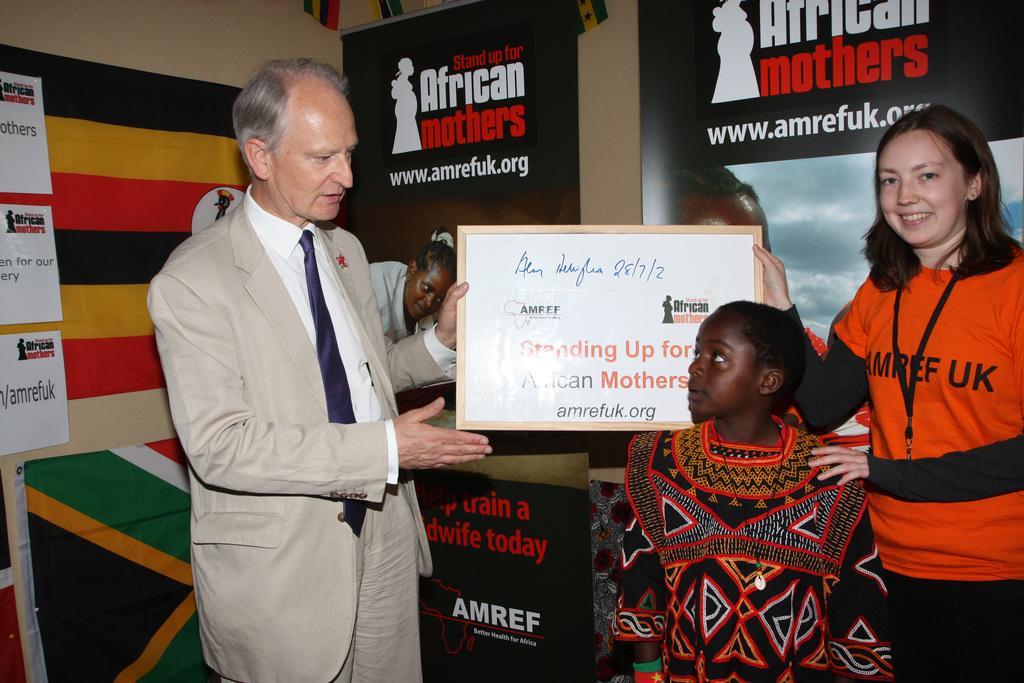In one or two sentences, can you explain what this image depicts? In this picture I can see there is a man standing and he is holding a certificate and there is a woman standing on the right side and there is a kid in front of her and in the backdrop there are a few posters pasted on the wall. 